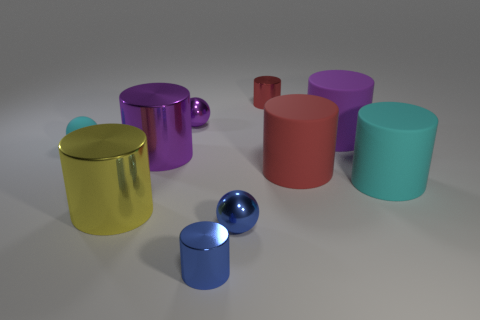Subtract 1 cylinders. How many cylinders are left? 6 Subtract all blue cylinders. How many cylinders are left? 6 Subtract all yellow metal cylinders. How many cylinders are left? 6 Subtract all yellow cylinders. Subtract all gray spheres. How many cylinders are left? 6 Subtract all balls. How many objects are left? 7 Add 2 matte objects. How many matte objects exist? 6 Subtract 0 gray cubes. How many objects are left? 10 Subtract all large purple rubber objects. Subtract all small red cylinders. How many objects are left? 8 Add 5 tiny blue cylinders. How many tiny blue cylinders are left? 6 